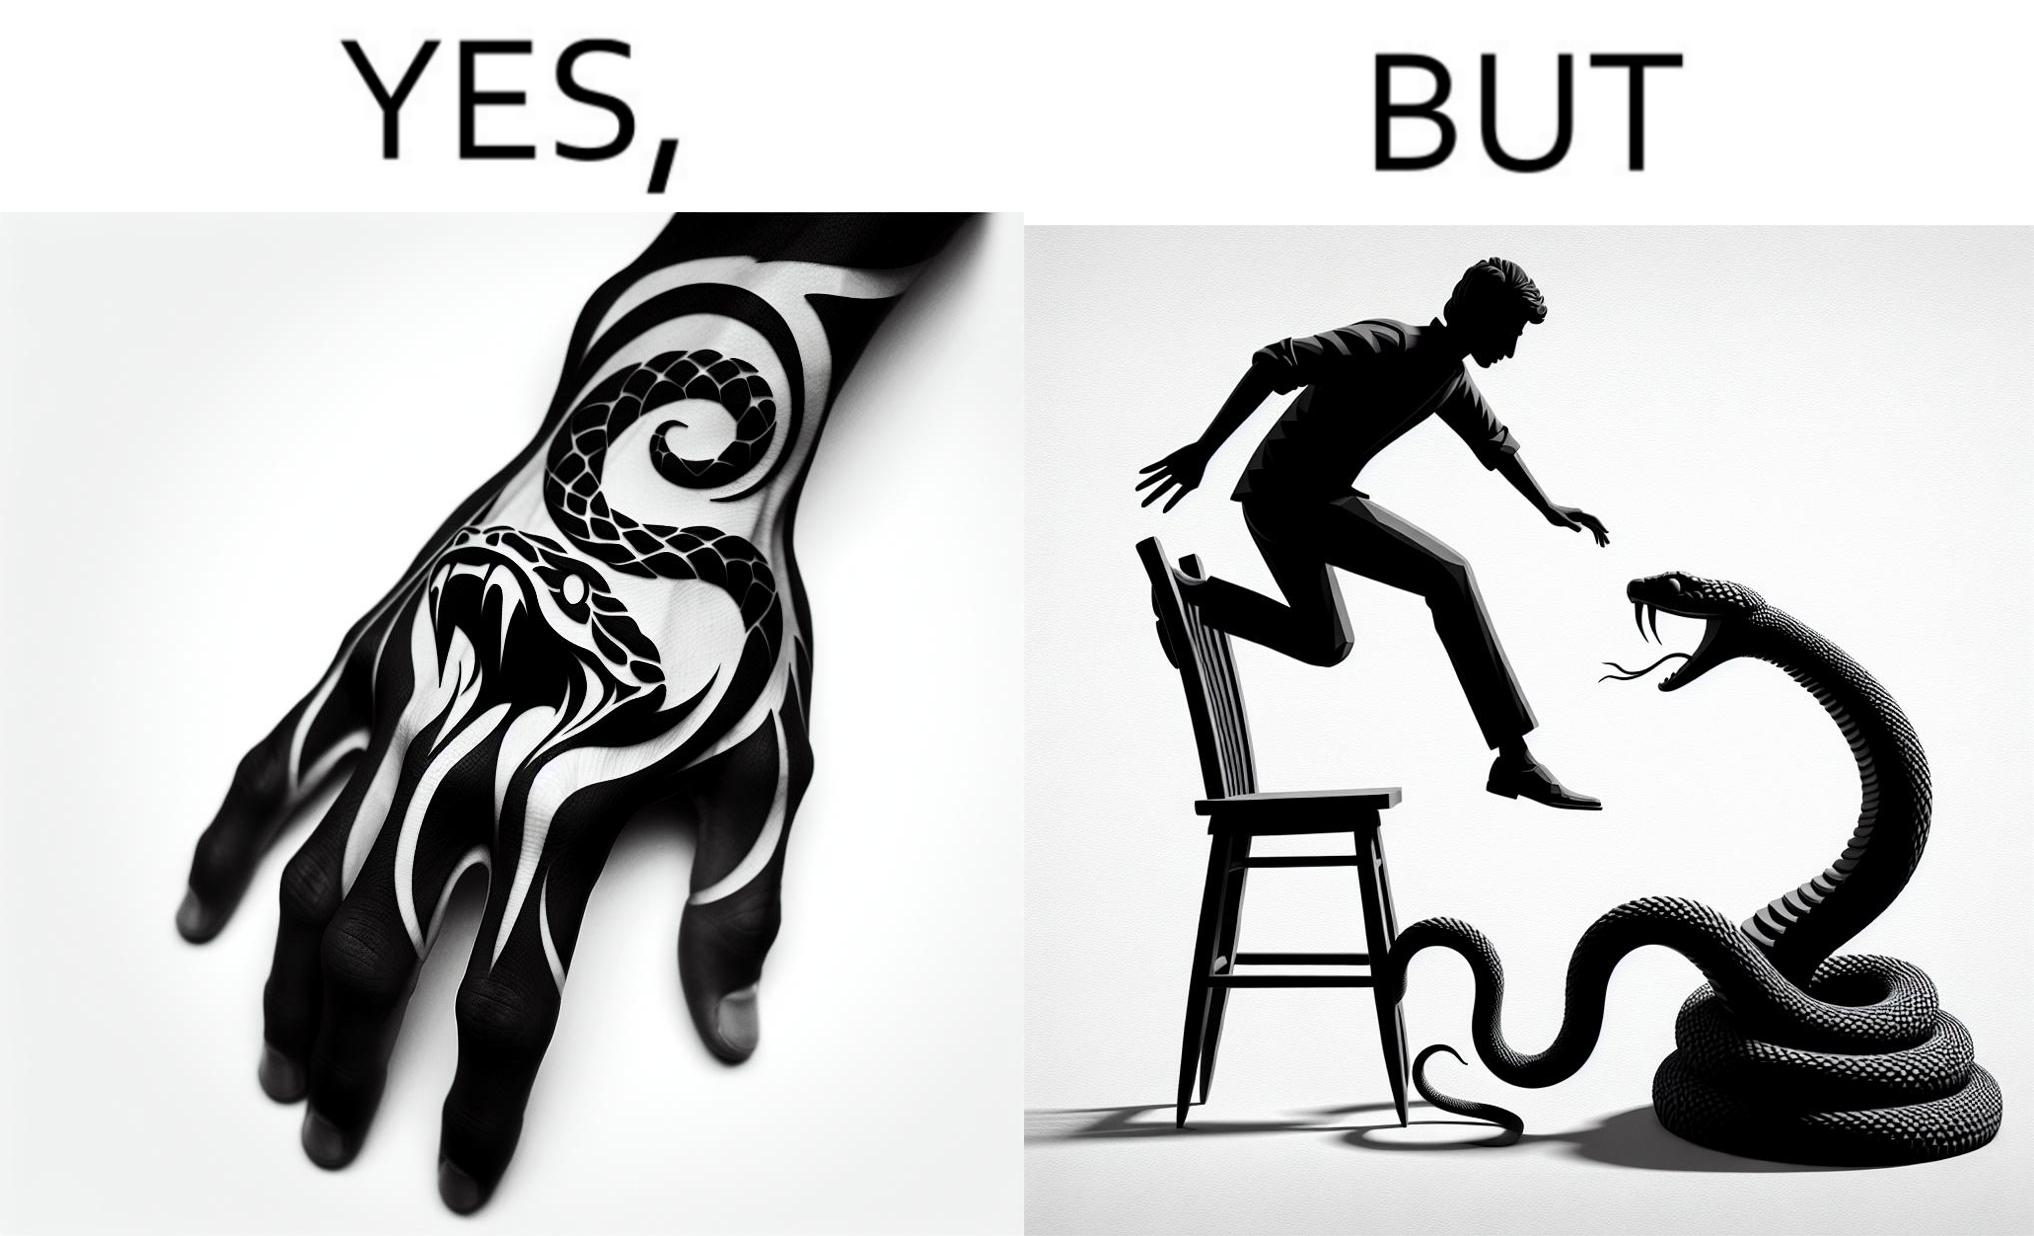What makes this image funny or satirical? The image is ironic, because in the first image the tattoo of a snake on someone's hand may give us a hint about how powerful or brave the person can be who is having this tattoo but in the second image the person with same tattoo is seen frightened due to a snake in his house 